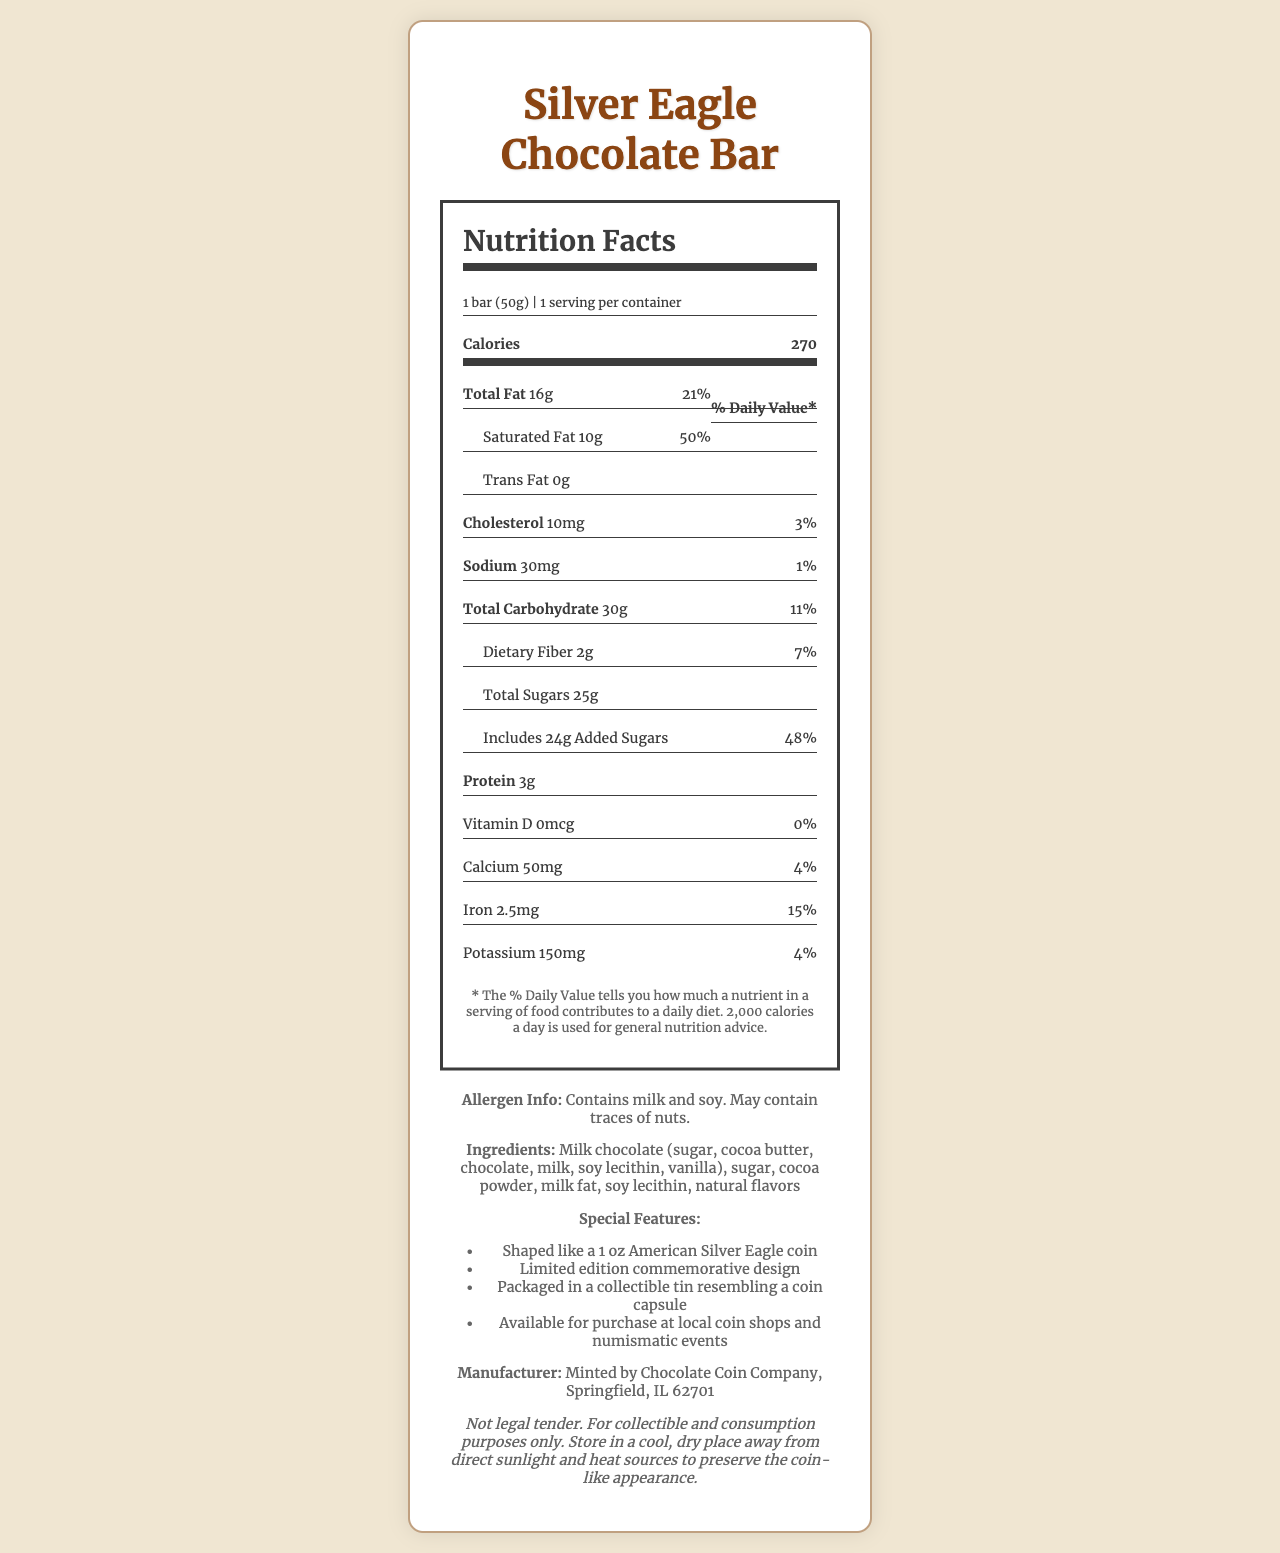what is the serving size? The serving size is mentioned at the top of the Nutrition Facts label: "Serving Size 1 bar (50g)".
Answer: 1 bar (50g) how many calories are in one serving? The Nutrition Facts label lists the calories for one serving as 270.
Answer: 270 how much saturated fat is in one serving? Under "Total Fat," the label details that the saturated fat content is 10g.
Answer: 10g what is the % Daily Value of total fat? The % Daily Value for total fat is indicated next to the total fat amount, which is 21%.
Answer: 21% how many grams of protein are in the bar? The amount of protein is listed as 3g on the Nutrition Facts label.
Answer: 3g which ingredient is listed first in the ingredients list? The ingredients list starts with "Milk chocolate (sugar, ...),” indicating sugar is the first ingredient.
Answer: Sugar what is the serving size of the Silver Eagle Chocolate Bar? A. 30g B. 50g C. 100g The serving size is specified as 1 bar (50g) in the document.
Answer: B. 50g which of the following is a feature of the Silver Eagle Chocolate Bar? I. Shaped like a 1 oz American Silver Eagle coin II. Can be bought online III. Available at local coin shops and numismatic events The document mentions it is "Shaped like a 1 oz American Silver Eagle coin" and is "Available for purchase at local coin shops and numismatic events."
Answer: I and III does the Silver Eagle Chocolate Bar contain any added sugars? The label lists "Includes 24g Added Sugars," indicating it contains added sugars.
Answer: Yes summarize the main idea of the document. The document offers comprehensive details about the Silver Eagle Chocolate Bar's nutritional profile, special features, allergen info, and buying options.
Answer: The document provides the nutritional information and features of the Silver Eagle Chocolate Bar, a limited edition chocolate shaped like an American Silver Eagle coin. It includes details on serving size, calorie content, macronutrient breakdown, ingredients, allergen information, and where to purchase it. what is the percentage of Daily Value for vitamin C in the chocolate bar? The document does not include any information about the vitamin C content or its % Daily Value.
Answer: Not enough information 